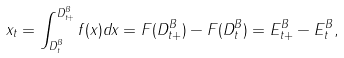Convert formula to latex. <formula><loc_0><loc_0><loc_500><loc_500>x _ { t } = \int _ { D ^ { B } _ { t } } ^ { D ^ { B } _ { t + } } f ( x ) d x = F ( D ^ { B } _ { t + } ) - F ( D ^ { B } _ { t } ) = E ^ { B } _ { t + } - E ^ { B } _ { t } ,</formula> 